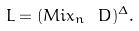<formula> <loc_0><loc_0><loc_500><loc_500>L = ( M i x _ { n } \ D ) ^ { \Delta } .</formula> 